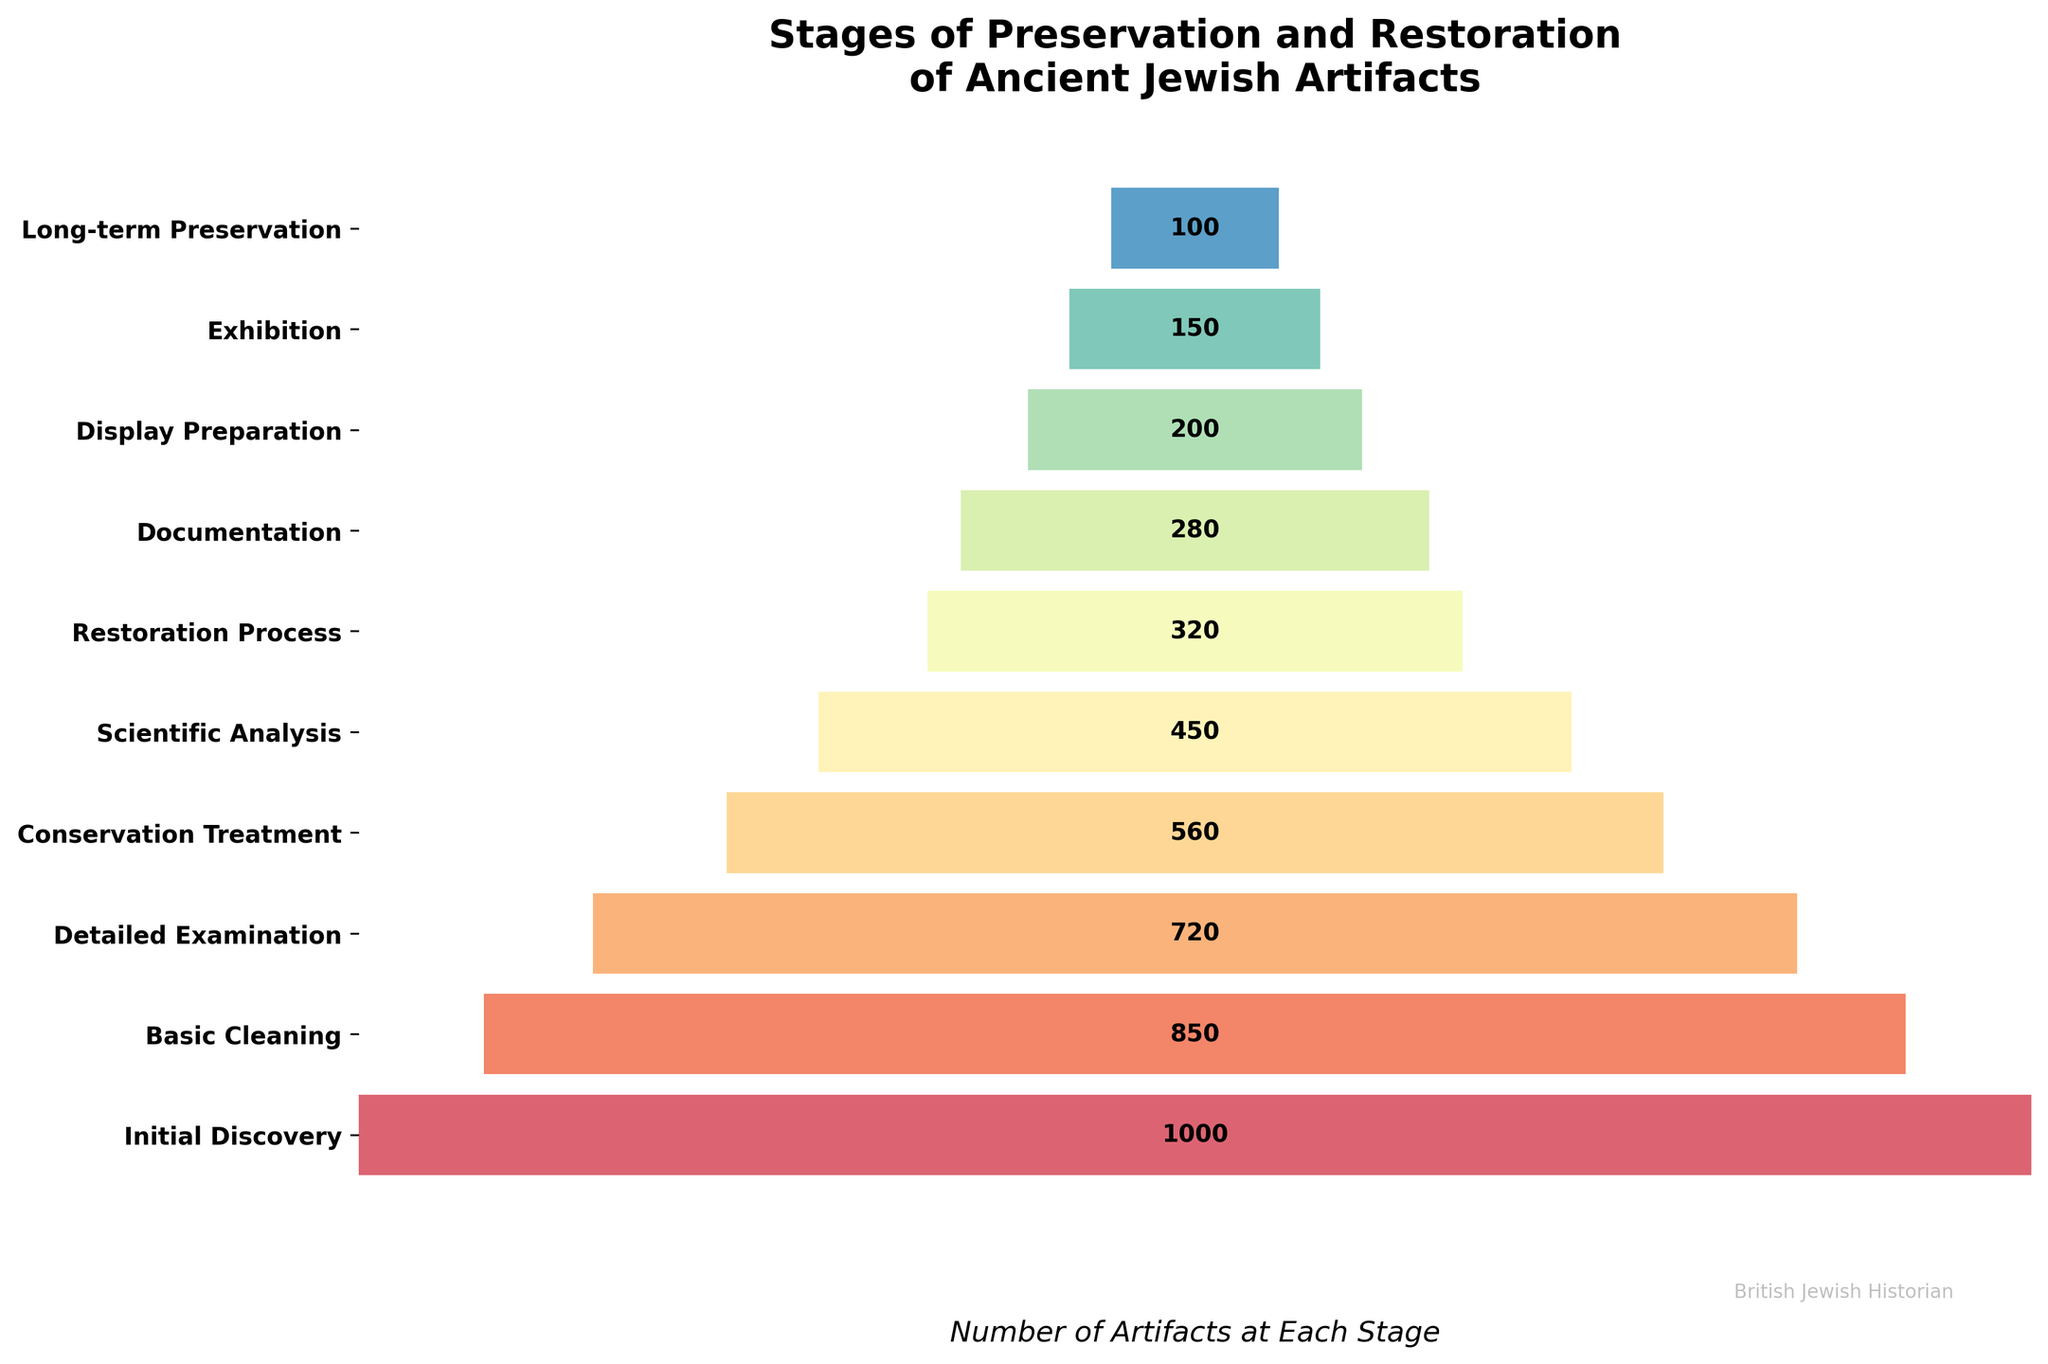What is the title of the funnel chart? The title is clearly located at the top of the chart and reads: "Stages of Preservation and Restoration of Ancient Jewish Artifacts".
Answer: Stages of Preservation and Restoration of Ancient Jewish Artifacts How many stages are represented in the funnel chart? By counting the number of horizontal bars in the funnel chart, we observe there are ten stages.
Answer: 10 Which stage has the highest number of artifacts? The highest number of artifacts is indicated by the widest bar, which is labeled "Initial Discovery" with 1000 artifacts.
Answer: Initial Discovery Which stage has the fewest number of artifacts? The narrowest bar, which indicates the fewest artifacts, corresponds to the "Long-term Preservation" stage with 100 artifacts.
Answer: Long-term Preservation What is the total number of artifacts across all stages? Summing the numbers of artifacts provided for each stage: (1000 + 850 + 720 + 560 + 450 + 320 + 280 + 200 + 150 + 100) = 4630.
Answer: 4630 How many more artifacts are there in the "Initial Discovery" stage compared to the "Documentation" stage? Subtract the artifacts in the "Documentation" stage (280) from the "Initial Discovery" stage (1000): 1000 - 280 = 720.
Answer: 720 What percentage of the initial artifacts reach the "Detailed Examination" stage? The percentage is calculated by dividing the number in the "Detailed Examination" stage (720) by the number in the "Initial Discovery" stage (1000) and multiplying by 100: (720 / 1000) * 100 = 72%.
Answer: 72% What is the difference in the number of artifacts between "Display Preparation" and "Exhibition"? Subtract the number of artifacts in the "Exhibition" stage (150) from the "Display Preparation" stage (200): 200 - 150 = 50.
Answer: 50 How many stages see a reduction of more than 300 artifacts from the previous stage? By analyzing each stage's differences, reductions of over 300 are found between: "Basic Cleaning" (850) to "Detailed Examination" (720) = 850 - 720 = 130; "Detailed Examination" (720) to "Conservation Treatment" (560) = 720 - 560 = 160; "Conservation Treatment" (560) to "Scientific Analysis" (450) = 560 - 450 = 110; "Scientific Analysis" (450) to "Restoration Process" (320) = 450 - 320 = 130; "Restoration Process" (320) to "Documentation" (280) = 320 - 280 = 40; "Documentation" (280) to "Display Preparation" (200) = 280 - 200 = 80; "Display Preparation" (200) to "Exhibition" (150) = 200 - 150 = 50; "Exhibition" (150) to "Long-term Preservation" (100) = 150 - 100 = 50. None of these differences exceed 300, so no stage sees a reduction of more than 300.
Answer: 0 Which stage marks a more than 50% reduction from its preceding stage? To find a more than 50% reduction, compare each stage to the preceding one. For instance, halve the numbers: "Initial Discovery" (1000 to 850) -> 1000 / 2 = 500; "Basic Cleaning" (850 to 720) -> 850 / 2 = 425; "Detailed Examination" (720 to 560) -> 720 / 2 = 360; "Conservation Treatment" (560 to 450) -> 560 / 2 = 280; "Scientific Analysis" (450 to 320) -> 450 / 2 = 225; "Restoration Process" (320 to 280) -> 320 / 2 = 160; "Documentation" (280 to 200) -> 280 / 2 = 140; "Display Preparation" (200 to 150) -> 200 / 2 = 100; "Exhibition" (150 to 100) -> 150 / 2 = 75; The only stage which has more than 50% reduction is from "Exhibition" to "Long-term Preservation".
Answer: Exhibition to Long-term Preservation 